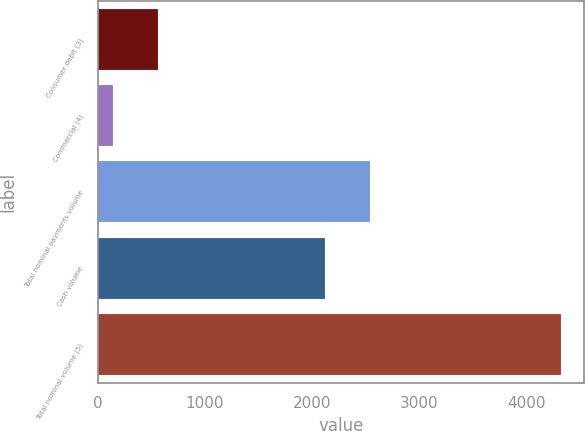<chart> <loc_0><loc_0><loc_500><loc_500><bar_chart><fcel>Consumer debit (3)<fcel>Commercial (4)<fcel>Total nominal payments volume<fcel>Cash volume<fcel>Total nominal volume (5)<nl><fcel>562.5<fcel>145<fcel>2539.5<fcel>2122<fcel>4320<nl></chart> 